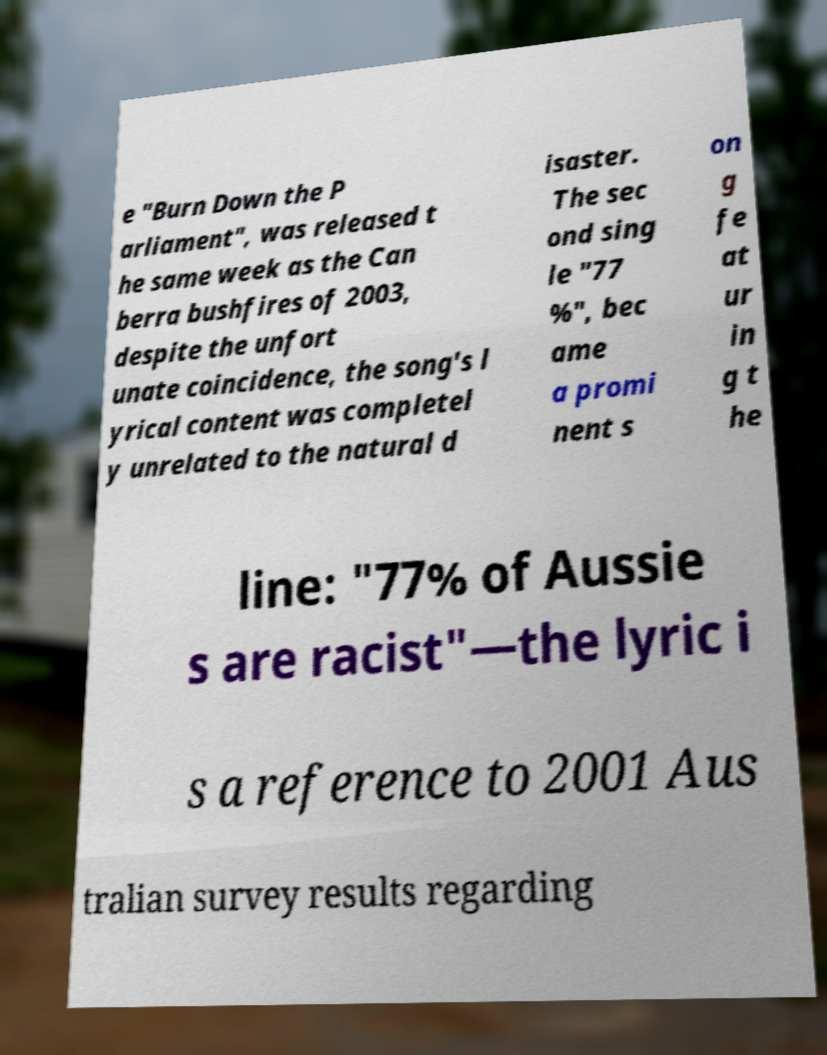Could you assist in decoding the text presented in this image and type it out clearly? e "Burn Down the P arliament", was released t he same week as the Can berra bushfires of 2003, despite the unfort unate coincidence, the song's l yrical content was completel y unrelated to the natural d isaster. The sec ond sing le "77 %", bec ame a promi nent s on g fe at ur in g t he line: "77% of Aussie s are racist"—the lyric i s a reference to 2001 Aus tralian survey results regarding 